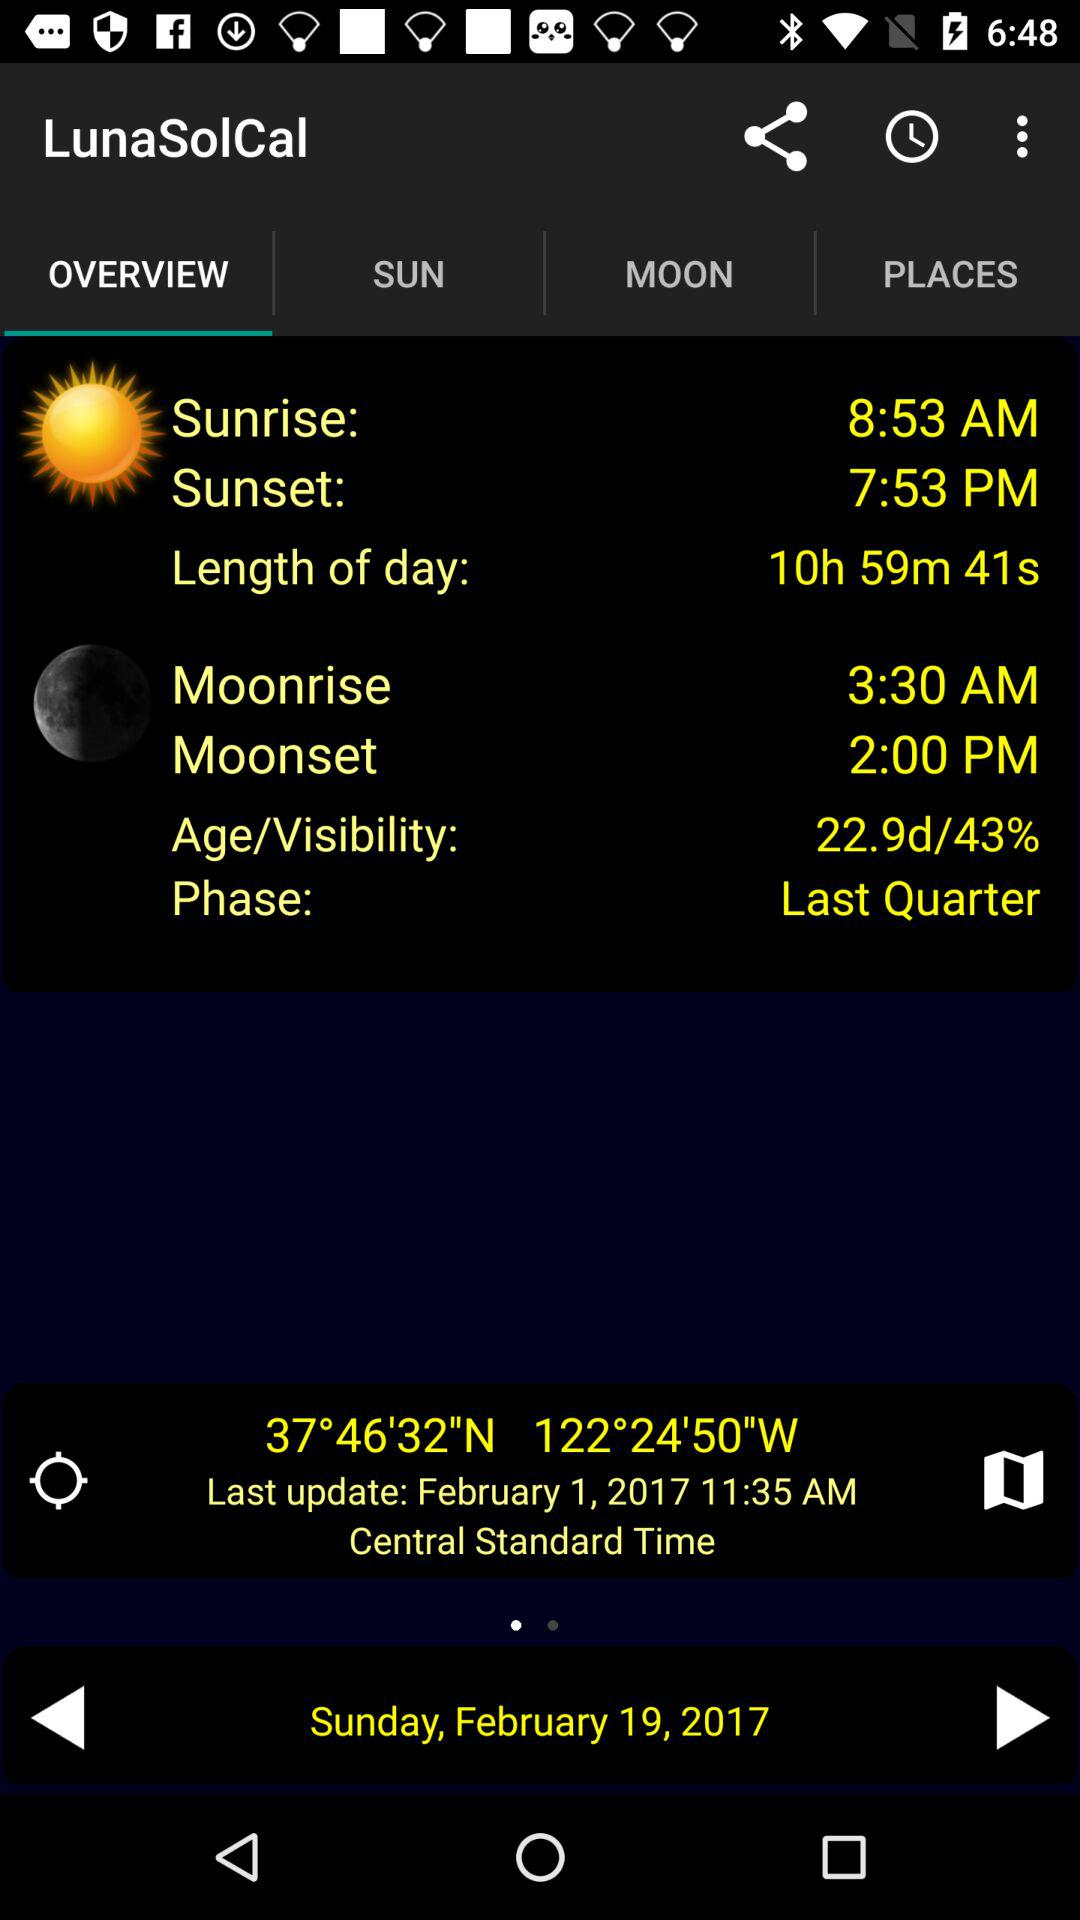What tab am I using? The tab is "OVERVIEW". 